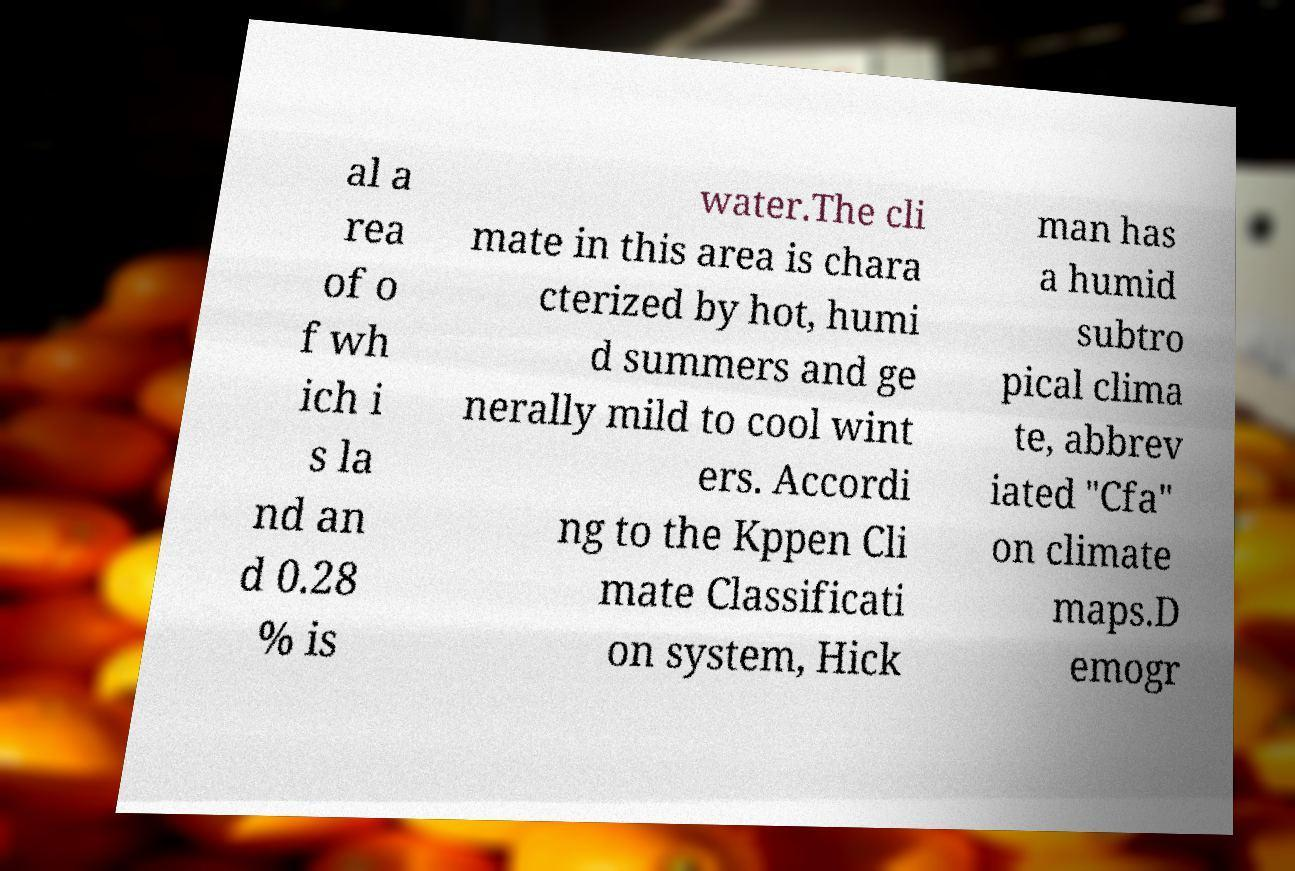What messages or text are displayed in this image? I need them in a readable, typed format. al a rea of o f wh ich i s la nd an d 0.28 % is water.The cli mate in this area is chara cterized by hot, humi d summers and ge nerally mild to cool wint ers. Accordi ng to the Kppen Cli mate Classificati on system, Hick man has a humid subtro pical clima te, abbrev iated "Cfa" on climate maps.D emogr 